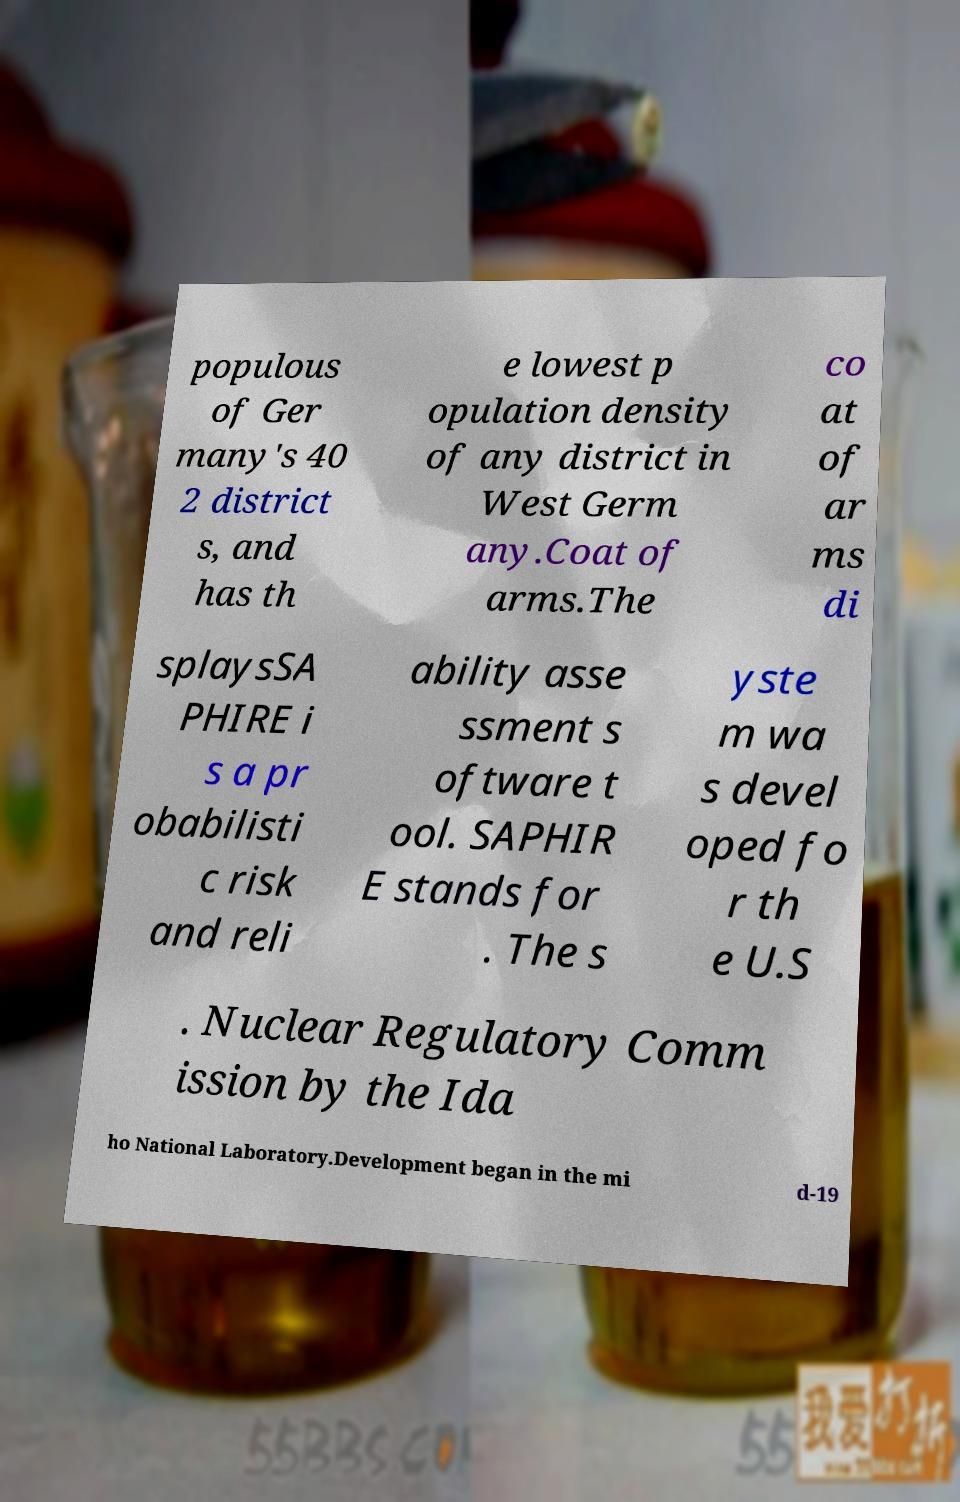Can you read and provide the text displayed in the image?This photo seems to have some interesting text. Can you extract and type it out for me? populous of Ger many's 40 2 district s, and has th e lowest p opulation density of any district in West Germ any.Coat of arms.The co at of ar ms di splaysSA PHIRE i s a pr obabilisti c risk and reli ability asse ssment s oftware t ool. SAPHIR E stands for . The s yste m wa s devel oped fo r th e U.S . Nuclear Regulatory Comm ission by the Ida ho National Laboratory.Development began in the mi d-19 